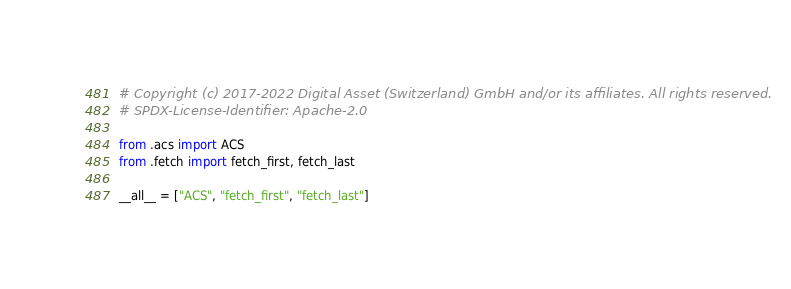Convert code to text. <code><loc_0><loc_0><loc_500><loc_500><_Python_># Copyright (c) 2017-2022 Digital Asset (Switzerland) GmbH and/or its affiliates. All rights reserved.
# SPDX-License-Identifier: Apache-2.0

from .acs import ACS
from .fetch import fetch_first, fetch_last

__all__ = ["ACS", "fetch_first", "fetch_last"]
</code> 